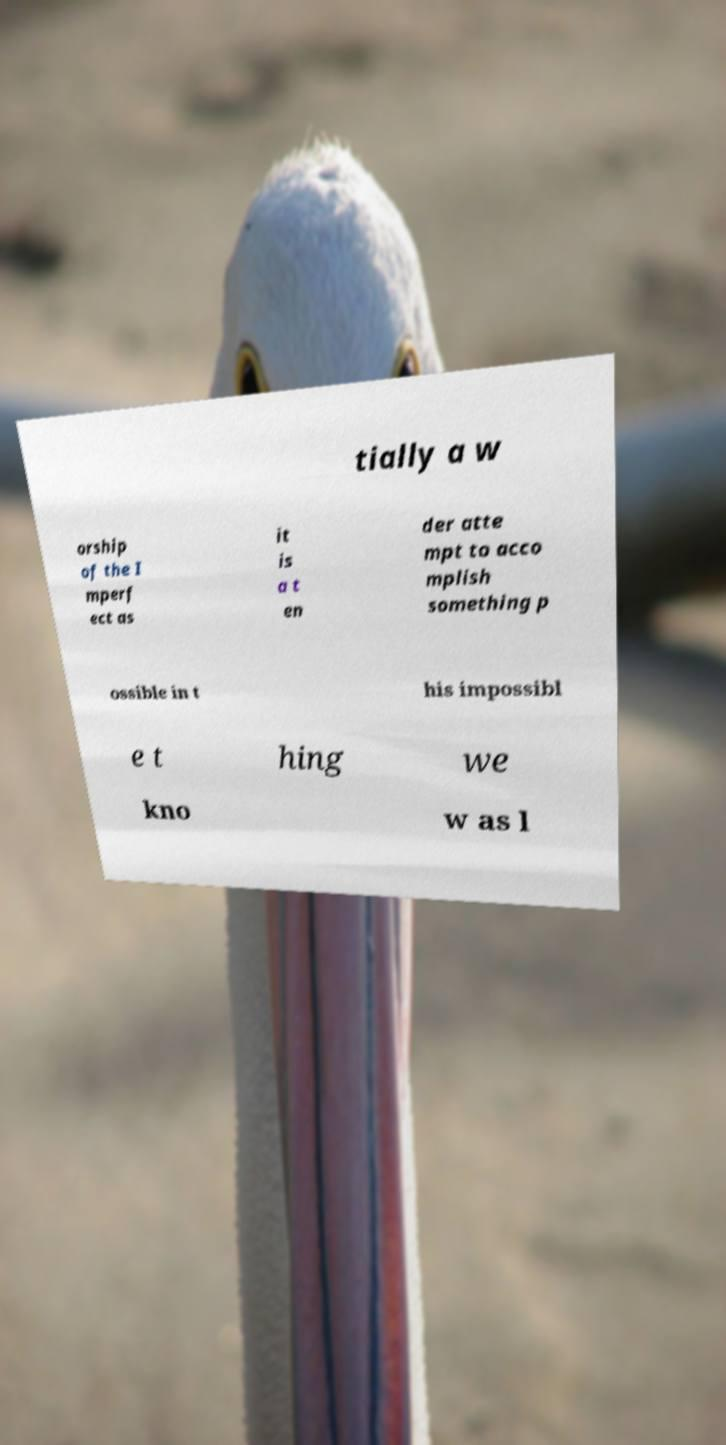Please read and relay the text visible in this image. What does it say? tially a w orship of the I mperf ect as it is a t en der atte mpt to acco mplish something p ossible in t his impossibl e t hing we kno w as l 